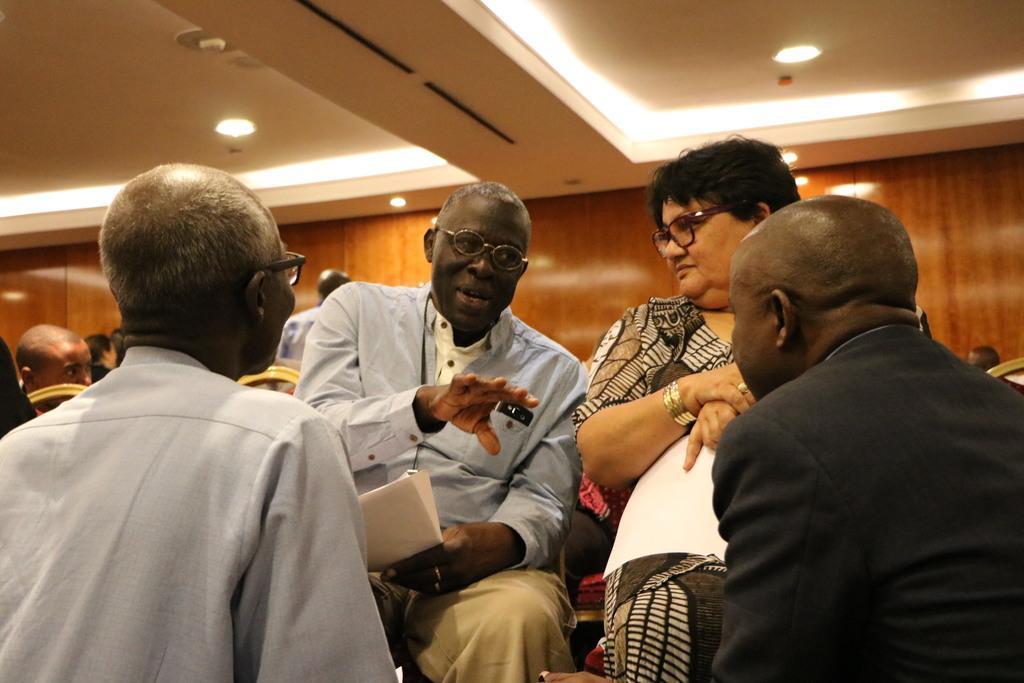In one or two sentences, can you explain what this image depicts? In this image there is an old man in the middle who is sitting on the chair by holding the papers. Beside him there is a woman who is sitting on the chair by holding the papers. In front of them there are two persons. At the top there is ceiling with the lights. In the background there are few people sitting in the chairs. 